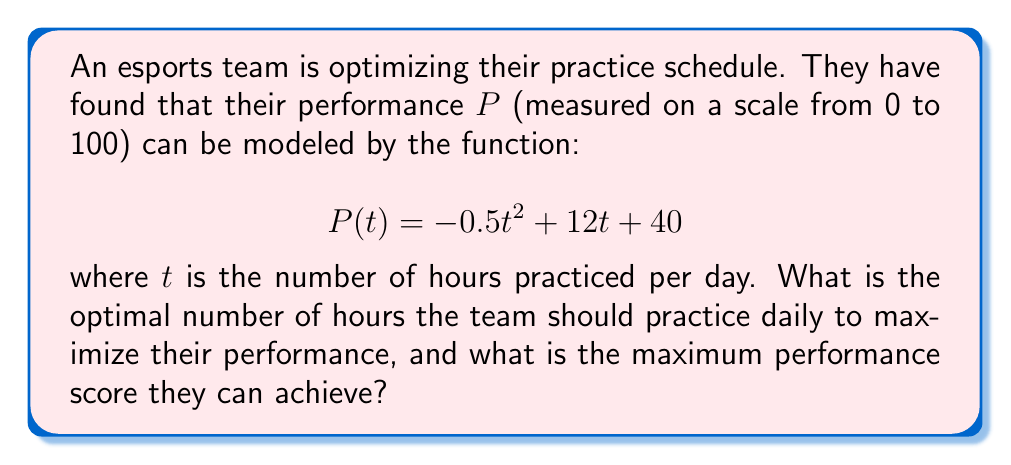Give your solution to this math problem. To find the optimal number of hours and maximum performance, we need to follow these steps:

1) The function $P(t)$ is a quadratic function, and its graph is a parabola. The maximum point of a parabola occurs at its vertex.

2) For a quadratic function in the form $f(t) = at^2 + bt + c$, the t-coordinate of the vertex is given by $t = -\frac{b}{2a}$.

3) In our case, $a = -0.5$, $b = 12$, and $c = 40$. Let's substitute these values:

   $t = -\frac{12}{2(-0.5)} = -\frac{12}{-1} = 12$

4) Therefore, the optimal number of practice hours is 12.

5) To find the maximum performance score, we substitute $t = 12$ into the original function:

   $$P(12) = -0.5(12)^2 + 12(12) + 40$$
   $$= -0.5(144) + 144 + 40$$
   $$= -72 + 144 + 40$$
   $$= 112$$

6) However, since the performance is measured on a scale from 0 to 100, we need to cap this at 100.

Therefore, the optimal practice time is 12 hours per day, which results in a maximum performance score of 100.
Answer: 12 hours; 100 